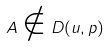Convert formula to latex. <formula><loc_0><loc_0><loc_500><loc_500>A \notin D ( u , p )</formula> 